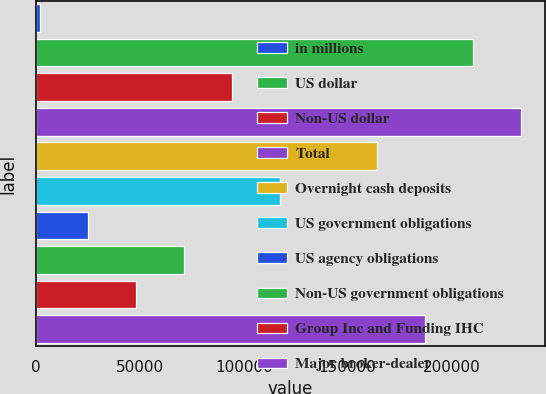Convert chart. <chart><loc_0><loc_0><loc_500><loc_500><bar_chart><fcel>in millions<fcel>US dollar<fcel>Non-US dollar<fcel>Total<fcel>Overnight cash deposits<fcel>US government obligations<fcel>US agency obligations<fcel>Non-US government obligations<fcel>Group Inc and Funding IHC<fcel>Major broker-dealer<nl><fcel>2018<fcel>210210<fcel>94548<fcel>233343<fcel>163946<fcel>117680<fcel>25150.5<fcel>71415.5<fcel>48283<fcel>187078<nl></chart> 